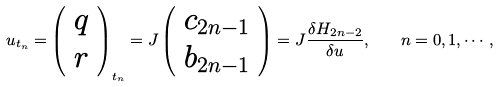<formula> <loc_0><loc_0><loc_500><loc_500>u _ { t _ { n } } = \left ( \begin{array} { c } q \\ r \end{array} \right ) _ { t _ { n } } = J \left ( \begin{array} { c } c _ { 2 n - 1 } \\ b _ { 2 n - 1 } \end{array} \right ) = J \frac { \delta H _ { 2 n - 2 } } { \delta u } , \quad n = 0 , 1 , \cdots ,</formula> 